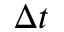<formula> <loc_0><loc_0><loc_500><loc_500>\Delta t</formula> 